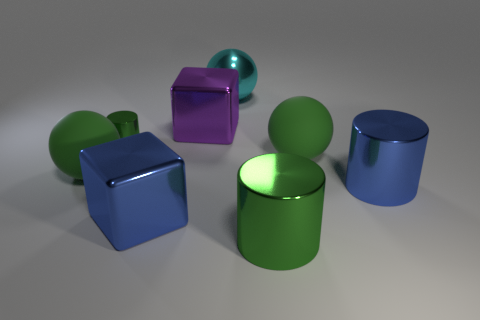Add 1 tiny green metal cylinders. How many objects exist? 9 Subtract all large green balls. How many balls are left? 1 Subtract all yellow cylinders. How many green spheres are left? 2 Subtract all blocks. How many objects are left? 6 Subtract all red cylinders. Subtract all blue blocks. How many cylinders are left? 3 Add 3 small yellow rubber cubes. How many small yellow rubber cubes exist? 3 Subtract 0 gray spheres. How many objects are left? 8 Subtract all large cyan metal things. Subtract all large blue shiny objects. How many objects are left? 5 Add 4 big metallic things. How many big metallic things are left? 9 